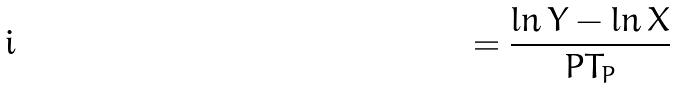<formula> <loc_0><loc_0><loc_500><loc_500>= \frac { \ln Y - \ln X } { P T _ { P } }</formula> 